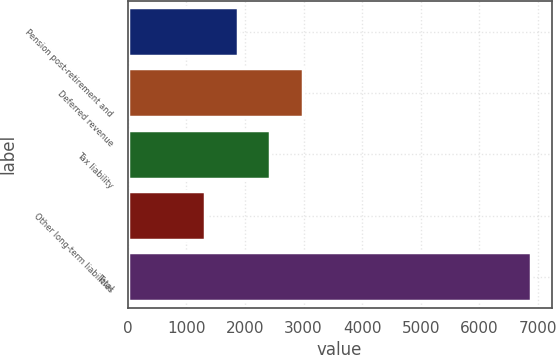<chart> <loc_0><loc_0><loc_500><loc_500><bar_chart><fcel>Pension post-retirement and<fcel>Deferred revenue<fcel>Tax liability<fcel>Other long-term liabilities<fcel>Total<nl><fcel>1876.5<fcel>2989.5<fcel>2433<fcel>1320<fcel>6885<nl></chart> 